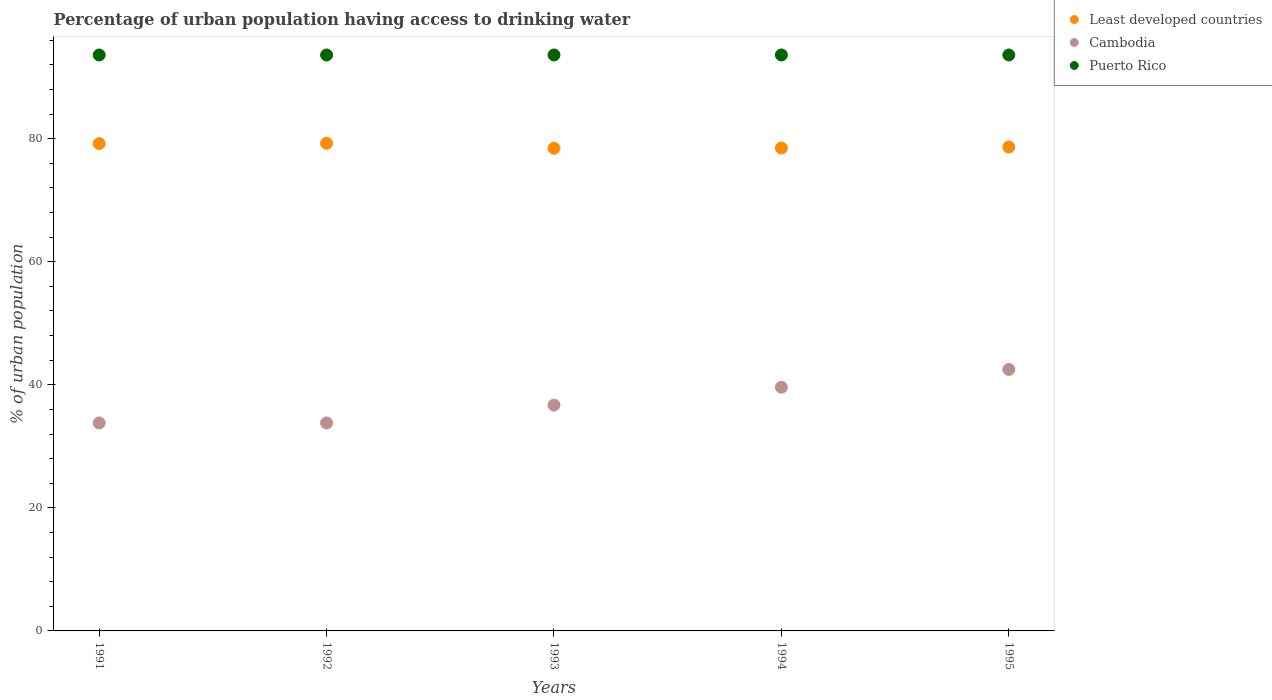How many different coloured dotlines are there?
Your answer should be very brief. 3. What is the percentage of urban population having access to drinking water in Cambodia in 1992?
Provide a short and direct response. 33.8. Across all years, what is the maximum percentage of urban population having access to drinking water in Puerto Rico?
Give a very brief answer. 93.6. Across all years, what is the minimum percentage of urban population having access to drinking water in Puerto Rico?
Offer a very short reply. 93.6. In which year was the percentage of urban population having access to drinking water in Least developed countries minimum?
Offer a terse response. 1993. What is the total percentage of urban population having access to drinking water in Cambodia in the graph?
Provide a short and direct response. 186.4. What is the difference between the percentage of urban population having access to drinking water in Cambodia in 1991 and the percentage of urban population having access to drinking water in Least developed countries in 1995?
Give a very brief answer. -44.84. What is the average percentage of urban population having access to drinking water in Puerto Rico per year?
Your answer should be very brief. 93.6. In the year 1991, what is the difference between the percentage of urban population having access to drinking water in Puerto Rico and percentage of urban population having access to drinking water in Least developed countries?
Provide a succinct answer. 14.4. What is the ratio of the percentage of urban population having access to drinking water in Least developed countries in 1992 to that in 1994?
Your response must be concise. 1.01. Is the difference between the percentage of urban population having access to drinking water in Puerto Rico in 1991 and 1992 greater than the difference between the percentage of urban population having access to drinking water in Least developed countries in 1991 and 1992?
Your answer should be compact. Yes. What is the difference between the highest and the second highest percentage of urban population having access to drinking water in Least developed countries?
Your answer should be compact. 0.05. What is the difference between the highest and the lowest percentage of urban population having access to drinking water in Least developed countries?
Your answer should be very brief. 0.81. Is the percentage of urban population having access to drinking water in Cambodia strictly greater than the percentage of urban population having access to drinking water in Puerto Rico over the years?
Your response must be concise. No. How many dotlines are there?
Ensure brevity in your answer.  3. How many years are there in the graph?
Offer a terse response. 5. Does the graph contain grids?
Offer a terse response. No. How are the legend labels stacked?
Your answer should be compact. Vertical. What is the title of the graph?
Offer a very short reply. Percentage of urban population having access to drinking water. What is the label or title of the Y-axis?
Provide a short and direct response. % of urban population. What is the % of urban population of Least developed countries in 1991?
Make the answer very short. 79.2. What is the % of urban population of Cambodia in 1991?
Your answer should be compact. 33.8. What is the % of urban population of Puerto Rico in 1991?
Offer a terse response. 93.6. What is the % of urban population of Least developed countries in 1992?
Ensure brevity in your answer.  79.25. What is the % of urban population in Cambodia in 1992?
Keep it short and to the point. 33.8. What is the % of urban population in Puerto Rico in 1992?
Offer a very short reply. 93.6. What is the % of urban population in Least developed countries in 1993?
Make the answer very short. 78.44. What is the % of urban population in Cambodia in 1993?
Give a very brief answer. 36.7. What is the % of urban population in Puerto Rico in 1993?
Offer a terse response. 93.6. What is the % of urban population in Least developed countries in 1994?
Your response must be concise. 78.48. What is the % of urban population in Cambodia in 1994?
Give a very brief answer. 39.6. What is the % of urban population of Puerto Rico in 1994?
Your answer should be very brief. 93.6. What is the % of urban population of Least developed countries in 1995?
Provide a succinct answer. 78.64. What is the % of urban population in Cambodia in 1995?
Your answer should be compact. 42.5. What is the % of urban population in Puerto Rico in 1995?
Provide a short and direct response. 93.6. Across all years, what is the maximum % of urban population of Least developed countries?
Offer a terse response. 79.25. Across all years, what is the maximum % of urban population of Cambodia?
Your response must be concise. 42.5. Across all years, what is the maximum % of urban population in Puerto Rico?
Offer a very short reply. 93.6. Across all years, what is the minimum % of urban population in Least developed countries?
Provide a short and direct response. 78.44. Across all years, what is the minimum % of urban population of Cambodia?
Your response must be concise. 33.8. Across all years, what is the minimum % of urban population of Puerto Rico?
Provide a succinct answer. 93.6. What is the total % of urban population of Least developed countries in the graph?
Provide a succinct answer. 394.01. What is the total % of urban population in Cambodia in the graph?
Your answer should be compact. 186.4. What is the total % of urban population of Puerto Rico in the graph?
Make the answer very short. 468. What is the difference between the % of urban population of Least developed countries in 1991 and that in 1992?
Provide a succinct answer. -0.05. What is the difference between the % of urban population of Cambodia in 1991 and that in 1992?
Make the answer very short. 0. What is the difference between the % of urban population of Puerto Rico in 1991 and that in 1992?
Your answer should be very brief. 0. What is the difference between the % of urban population in Least developed countries in 1991 and that in 1993?
Your answer should be compact. 0.76. What is the difference between the % of urban population of Least developed countries in 1991 and that in 1994?
Keep it short and to the point. 0.72. What is the difference between the % of urban population in Puerto Rico in 1991 and that in 1994?
Your answer should be very brief. 0. What is the difference between the % of urban population in Least developed countries in 1991 and that in 1995?
Your answer should be very brief. 0.56. What is the difference between the % of urban population in Cambodia in 1991 and that in 1995?
Ensure brevity in your answer.  -8.7. What is the difference between the % of urban population of Puerto Rico in 1991 and that in 1995?
Your answer should be very brief. 0. What is the difference between the % of urban population in Least developed countries in 1992 and that in 1993?
Offer a terse response. 0.81. What is the difference between the % of urban population of Puerto Rico in 1992 and that in 1993?
Make the answer very short. 0. What is the difference between the % of urban population in Least developed countries in 1992 and that in 1994?
Your answer should be compact. 0.77. What is the difference between the % of urban population of Least developed countries in 1992 and that in 1995?
Provide a short and direct response. 0.61. What is the difference between the % of urban population in Cambodia in 1992 and that in 1995?
Offer a terse response. -8.7. What is the difference between the % of urban population of Least developed countries in 1993 and that in 1994?
Give a very brief answer. -0.04. What is the difference between the % of urban population of Least developed countries in 1993 and that in 1995?
Provide a succinct answer. -0.2. What is the difference between the % of urban population of Puerto Rico in 1993 and that in 1995?
Ensure brevity in your answer.  0. What is the difference between the % of urban population in Least developed countries in 1994 and that in 1995?
Offer a very short reply. -0.16. What is the difference between the % of urban population in Puerto Rico in 1994 and that in 1995?
Provide a short and direct response. 0. What is the difference between the % of urban population of Least developed countries in 1991 and the % of urban population of Cambodia in 1992?
Your response must be concise. 45.4. What is the difference between the % of urban population in Least developed countries in 1991 and the % of urban population in Puerto Rico in 1992?
Make the answer very short. -14.4. What is the difference between the % of urban population in Cambodia in 1991 and the % of urban population in Puerto Rico in 1992?
Make the answer very short. -59.8. What is the difference between the % of urban population in Least developed countries in 1991 and the % of urban population in Cambodia in 1993?
Keep it short and to the point. 42.5. What is the difference between the % of urban population of Least developed countries in 1991 and the % of urban population of Puerto Rico in 1993?
Keep it short and to the point. -14.4. What is the difference between the % of urban population in Cambodia in 1991 and the % of urban population in Puerto Rico in 1993?
Your answer should be very brief. -59.8. What is the difference between the % of urban population of Least developed countries in 1991 and the % of urban population of Cambodia in 1994?
Offer a terse response. 39.6. What is the difference between the % of urban population in Least developed countries in 1991 and the % of urban population in Puerto Rico in 1994?
Offer a terse response. -14.4. What is the difference between the % of urban population of Cambodia in 1991 and the % of urban population of Puerto Rico in 1994?
Provide a succinct answer. -59.8. What is the difference between the % of urban population of Least developed countries in 1991 and the % of urban population of Cambodia in 1995?
Give a very brief answer. 36.7. What is the difference between the % of urban population of Least developed countries in 1991 and the % of urban population of Puerto Rico in 1995?
Your answer should be compact. -14.4. What is the difference between the % of urban population in Cambodia in 1991 and the % of urban population in Puerto Rico in 1995?
Your answer should be compact. -59.8. What is the difference between the % of urban population of Least developed countries in 1992 and the % of urban population of Cambodia in 1993?
Provide a short and direct response. 42.55. What is the difference between the % of urban population of Least developed countries in 1992 and the % of urban population of Puerto Rico in 1993?
Your answer should be very brief. -14.35. What is the difference between the % of urban population of Cambodia in 1992 and the % of urban population of Puerto Rico in 1993?
Make the answer very short. -59.8. What is the difference between the % of urban population in Least developed countries in 1992 and the % of urban population in Cambodia in 1994?
Provide a succinct answer. 39.65. What is the difference between the % of urban population of Least developed countries in 1992 and the % of urban population of Puerto Rico in 1994?
Your response must be concise. -14.35. What is the difference between the % of urban population in Cambodia in 1992 and the % of urban population in Puerto Rico in 1994?
Ensure brevity in your answer.  -59.8. What is the difference between the % of urban population in Least developed countries in 1992 and the % of urban population in Cambodia in 1995?
Keep it short and to the point. 36.75. What is the difference between the % of urban population of Least developed countries in 1992 and the % of urban population of Puerto Rico in 1995?
Provide a short and direct response. -14.35. What is the difference between the % of urban population in Cambodia in 1992 and the % of urban population in Puerto Rico in 1995?
Make the answer very short. -59.8. What is the difference between the % of urban population of Least developed countries in 1993 and the % of urban population of Cambodia in 1994?
Your answer should be very brief. 38.84. What is the difference between the % of urban population in Least developed countries in 1993 and the % of urban population in Puerto Rico in 1994?
Ensure brevity in your answer.  -15.16. What is the difference between the % of urban population in Cambodia in 1993 and the % of urban population in Puerto Rico in 1994?
Make the answer very short. -56.9. What is the difference between the % of urban population of Least developed countries in 1993 and the % of urban population of Cambodia in 1995?
Keep it short and to the point. 35.94. What is the difference between the % of urban population of Least developed countries in 1993 and the % of urban population of Puerto Rico in 1995?
Offer a terse response. -15.16. What is the difference between the % of urban population in Cambodia in 1993 and the % of urban population in Puerto Rico in 1995?
Give a very brief answer. -56.9. What is the difference between the % of urban population of Least developed countries in 1994 and the % of urban population of Cambodia in 1995?
Your answer should be very brief. 35.98. What is the difference between the % of urban population of Least developed countries in 1994 and the % of urban population of Puerto Rico in 1995?
Ensure brevity in your answer.  -15.12. What is the difference between the % of urban population in Cambodia in 1994 and the % of urban population in Puerto Rico in 1995?
Provide a succinct answer. -54. What is the average % of urban population in Least developed countries per year?
Your response must be concise. 78.8. What is the average % of urban population of Cambodia per year?
Offer a terse response. 37.28. What is the average % of urban population of Puerto Rico per year?
Provide a short and direct response. 93.6. In the year 1991, what is the difference between the % of urban population of Least developed countries and % of urban population of Cambodia?
Offer a terse response. 45.4. In the year 1991, what is the difference between the % of urban population of Least developed countries and % of urban population of Puerto Rico?
Give a very brief answer. -14.4. In the year 1991, what is the difference between the % of urban population in Cambodia and % of urban population in Puerto Rico?
Give a very brief answer. -59.8. In the year 1992, what is the difference between the % of urban population in Least developed countries and % of urban population in Cambodia?
Your response must be concise. 45.45. In the year 1992, what is the difference between the % of urban population in Least developed countries and % of urban population in Puerto Rico?
Provide a succinct answer. -14.35. In the year 1992, what is the difference between the % of urban population of Cambodia and % of urban population of Puerto Rico?
Make the answer very short. -59.8. In the year 1993, what is the difference between the % of urban population in Least developed countries and % of urban population in Cambodia?
Keep it short and to the point. 41.74. In the year 1993, what is the difference between the % of urban population of Least developed countries and % of urban population of Puerto Rico?
Provide a succinct answer. -15.16. In the year 1993, what is the difference between the % of urban population of Cambodia and % of urban population of Puerto Rico?
Your response must be concise. -56.9. In the year 1994, what is the difference between the % of urban population of Least developed countries and % of urban population of Cambodia?
Provide a short and direct response. 38.88. In the year 1994, what is the difference between the % of urban population in Least developed countries and % of urban population in Puerto Rico?
Your response must be concise. -15.12. In the year 1994, what is the difference between the % of urban population in Cambodia and % of urban population in Puerto Rico?
Your answer should be very brief. -54. In the year 1995, what is the difference between the % of urban population of Least developed countries and % of urban population of Cambodia?
Your response must be concise. 36.14. In the year 1995, what is the difference between the % of urban population of Least developed countries and % of urban population of Puerto Rico?
Offer a terse response. -14.96. In the year 1995, what is the difference between the % of urban population of Cambodia and % of urban population of Puerto Rico?
Provide a succinct answer. -51.1. What is the ratio of the % of urban population in Least developed countries in 1991 to that in 1992?
Provide a short and direct response. 1. What is the ratio of the % of urban population of Cambodia in 1991 to that in 1992?
Offer a very short reply. 1. What is the ratio of the % of urban population of Least developed countries in 1991 to that in 1993?
Keep it short and to the point. 1.01. What is the ratio of the % of urban population of Cambodia in 1991 to that in 1993?
Offer a terse response. 0.92. What is the ratio of the % of urban population in Puerto Rico in 1991 to that in 1993?
Provide a short and direct response. 1. What is the ratio of the % of urban population of Least developed countries in 1991 to that in 1994?
Keep it short and to the point. 1.01. What is the ratio of the % of urban population in Cambodia in 1991 to that in 1994?
Keep it short and to the point. 0.85. What is the ratio of the % of urban population of Puerto Rico in 1991 to that in 1994?
Give a very brief answer. 1. What is the ratio of the % of urban population in Least developed countries in 1991 to that in 1995?
Ensure brevity in your answer.  1.01. What is the ratio of the % of urban population in Cambodia in 1991 to that in 1995?
Provide a short and direct response. 0.8. What is the ratio of the % of urban population in Puerto Rico in 1991 to that in 1995?
Ensure brevity in your answer.  1. What is the ratio of the % of urban population in Least developed countries in 1992 to that in 1993?
Offer a very short reply. 1.01. What is the ratio of the % of urban population in Cambodia in 1992 to that in 1993?
Provide a succinct answer. 0.92. What is the ratio of the % of urban population in Least developed countries in 1992 to that in 1994?
Provide a short and direct response. 1.01. What is the ratio of the % of urban population of Cambodia in 1992 to that in 1994?
Your answer should be compact. 0.85. What is the ratio of the % of urban population in Least developed countries in 1992 to that in 1995?
Keep it short and to the point. 1.01. What is the ratio of the % of urban population in Cambodia in 1992 to that in 1995?
Your answer should be very brief. 0.8. What is the ratio of the % of urban population in Puerto Rico in 1992 to that in 1995?
Make the answer very short. 1. What is the ratio of the % of urban population in Cambodia in 1993 to that in 1994?
Your answer should be compact. 0.93. What is the ratio of the % of urban population of Puerto Rico in 1993 to that in 1994?
Keep it short and to the point. 1. What is the ratio of the % of urban population in Least developed countries in 1993 to that in 1995?
Provide a succinct answer. 1. What is the ratio of the % of urban population of Cambodia in 1993 to that in 1995?
Your response must be concise. 0.86. What is the ratio of the % of urban population in Puerto Rico in 1993 to that in 1995?
Provide a short and direct response. 1. What is the ratio of the % of urban population of Cambodia in 1994 to that in 1995?
Your response must be concise. 0.93. What is the difference between the highest and the second highest % of urban population in Least developed countries?
Ensure brevity in your answer.  0.05. What is the difference between the highest and the lowest % of urban population in Least developed countries?
Give a very brief answer. 0.81. What is the difference between the highest and the lowest % of urban population of Cambodia?
Provide a short and direct response. 8.7. What is the difference between the highest and the lowest % of urban population of Puerto Rico?
Offer a very short reply. 0. 